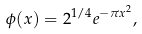<formula> <loc_0><loc_0><loc_500><loc_500>\phi ( x ) = 2 ^ { 1 / 4 } e ^ { - \pi x ^ { 2 } } ,</formula> 